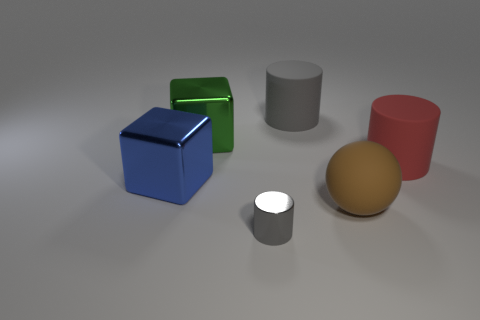Do the metal cylinder on the right side of the green cube and the green metal block have the same size?
Keep it short and to the point. No. There is a big rubber cylinder that is to the right of the gray cylinder that is behind the cylinder that is in front of the large blue cube; what is its color?
Your answer should be compact. Red. The big sphere has what color?
Make the answer very short. Brown. Is the ball the same color as the tiny metallic object?
Offer a very short reply. No. Do the cylinder in front of the brown ball and the gray thing behind the small gray object have the same material?
Make the answer very short. No. What material is the big red thing that is the same shape as the gray metal object?
Provide a succinct answer. Rubber. Is the brown sphere made of the same material as the green object?
Offer a terse response. No. What color is the large matte thing in front of the big matte cylinder to the right of the gray rubber cylinder?
Offer a very short reply. Brown. There is a gray object that is made of the same material as the ball; what size is it?
Your answer should be very brief. Large. What number of other gray rubber objects have the same shape as the tiny gray thing?
Ensure brevity in your answer.  1. 